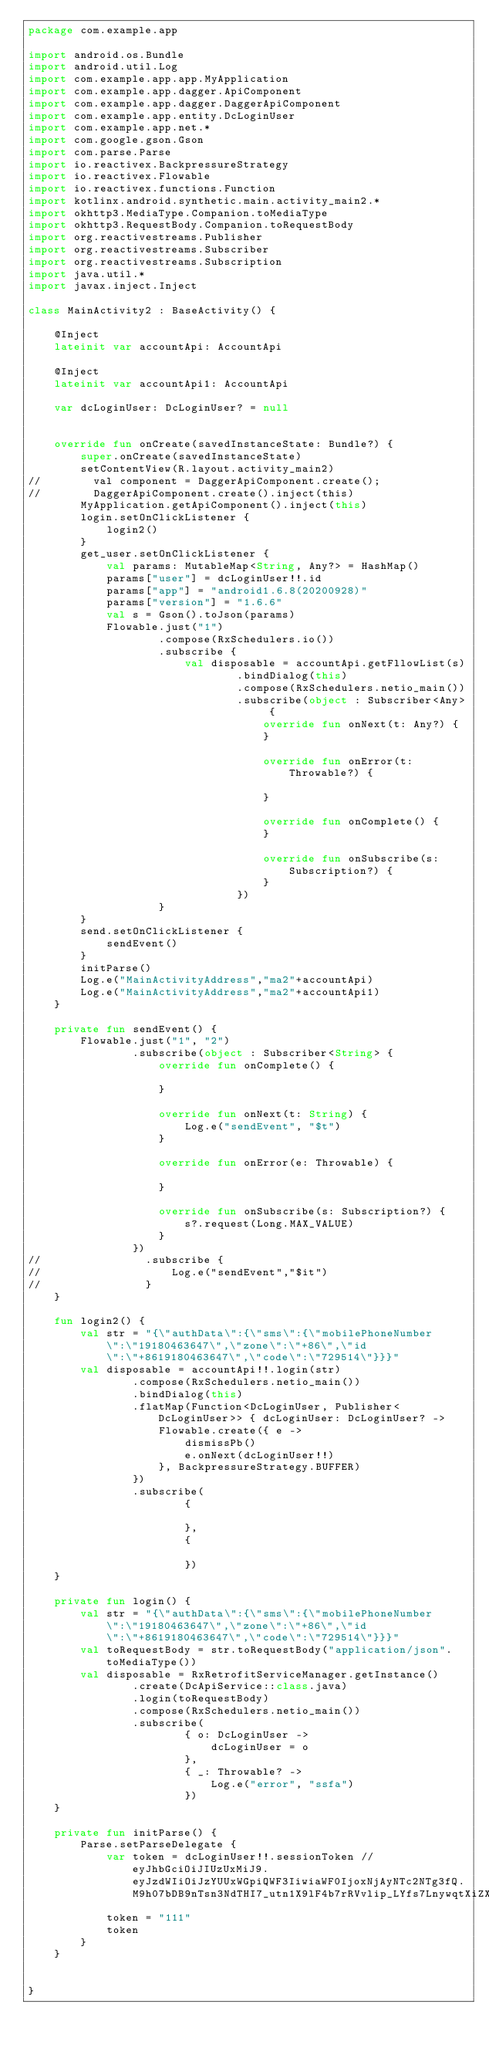<code> <loc_0><loc_0><loc_500><loc_500><_Kotlin_>package com.example.app

import android.os.Bundle
import android.util.Log
import com.example.app.app.MyApplication
import com.example.app.dagger.ApiComponent
import com.example.app.dagger.DaggerApiComponent
import com.example.app.entity.DcLoginUser
import com.example.app.net.*
import com.google.gson.Gson
import com.parse.Parse
import io.reactivex.BackpressureStrategy
import io.reactivex.Flowable
import io.reactivex.functions.Function
import kotlinx.android.synthetic.main.activity_main2.*
import okhttp3.MediaType.Companion.toMediaType
import okhttp3.RequestBody.Companion.toRequestBody
import org.reactivestreams.Publisher
import org.reactivestreams.Subscriber
import org.reactivestreams.Subscription
import java.util.*
import javax.inject.Inject

class MainActivity2 : BaseActivity() {

    @Inject
    lateinit var accountApi: AccountApi

    @Inject
    lateinit var accountApi1: AccountApi

    var dcLoginUser: DcLoginUser? = null


    override fun onCreate(savedInstanceState: Bundle?) {
        super.onCreate(savedInstanceState)
        setContentView(R.layout.activity_main2)
//        val component = DaggerApiComponent.create();
//        DaggerApiComponent.create().inject(this)
        MyApplication.getApiComponent().inject(this)
        login.setOnClickListener {
            login2()
        }
        get_user.setOnClickListener {
            val params: MutableMap<String, Any?> = HashMap()
            params["user"] = dcLoginUser!!.id
            params["app"] = "android1.6.8(20200928)"
            params["version"] = "1.6.6"
            val s = Gson().toJson(params)
            Flowable.just("1")
                    .compose(RxSchedulers.io())
                    .subscribe {
                        val disposable = accountApi.getFllowList(s)
                                .bindDialog(this)
                                .compose(RxSchedulers.netio_main())
                                .subscribe(object : Subscriber<Any> {
                                    override fun onNext(t: Any?) {
                                    }

                                    override fun onError(t: Throwable?) {

                                    }

                                    override fun onComplete() {
                                    }

                                    override fun onSubscribe(s: Subscription?) {
                                    }
                                })
                    }
        }
        send.setOnClickListener {
            sendEvent()
        }
        initParse()
        Log.e("MainActivityAddress","ma2"+accountApi)
        Log.e("MainActivityAddress","ma2"+accountApi1)
    }

    private fun sendEvent() {
        Flowable.just("1", "2")
                .subscribe(object : Subscriber<String> {
                    override fun onComplete() {

                    }

                    override fun onNext(t: String) {
                        Log.e("sendEvent", "$t")
                    }

                    override fun onError(e: Throwable) {

                    }

                    override fun onSubscribe(s: Subscription?) {
                        s?.request(Long.MAX_VALUE)
                    }
                })
//                .subscribe {
//                    Log.e("sendEvent","$it")
//                }
    }

    fun login2() {
        val str = "{\"authData\":{\"sms\":{\"mobilePhoneNumber\":\"19180463647\",\"zone\":\"+86\",\"id\":\"+8619180463647\",\"code\":\"729514\"}}}"
        val disposable = accountApi!!.login(str)
                .compose(RxSchedulers.netio_main())
                .bindDialog(this)
                .flatMap(Function<DcLoginUser, Publisher<DcLoginUser>> { dcLoginUser: DcLoginUser? ->
                    Flowable.create({ e ->
                        dismissPb()
                        e.onNext(dcLoginUser!!)
                    }, BackpressureStrategy.BUFFER)
                })
                .subscribe(
                        {

                        },
                        {

                        })
    }

    private fun login() {
        val str = "{\"authData\":{\"sms\":{\"mobilePhoneNumber\":\"19180463647\",\"zone\":\"+86\",\"id\":\"+8619180463647\",\"code\":\"729514\"}}}"
        val toRequestBody = str.toRequestBody("application/json".toMediaType())
        val disposable = RxRetrofitServiceManager.getInstance()
                .create(DcApiService::class.java)
                .login(toRequestBody)
                .compose(RxSchedulers.netio_main())
                .subscribe(
                        { o: DcLoginUser ->
                            dcLoginUser = o
                        },
                        { _: Throwable? ->
                            Log.e("error", "ssfa")
                        })
    }

    private fun initParse() {
        Parse.setParseDelegate {
            var token = dcLoginUser!!.sessionToken //eyJhbGciOiJIUzUxMiJ9.eyJzdWIiOiJzYUUxWGpiQWF3IiwiaWF0IjoxNjAyNTc2NTg3fQ.M9h07bDB9nTsn3NdTHI7_utn1X9lF4b7rRVvlip_LYfs7LnywqtXiZXJ1UVhBAB6Bnjv8aZ41nJbGMIhCdio9A
            token = "111"
            token
        }
    }


}


</code> 